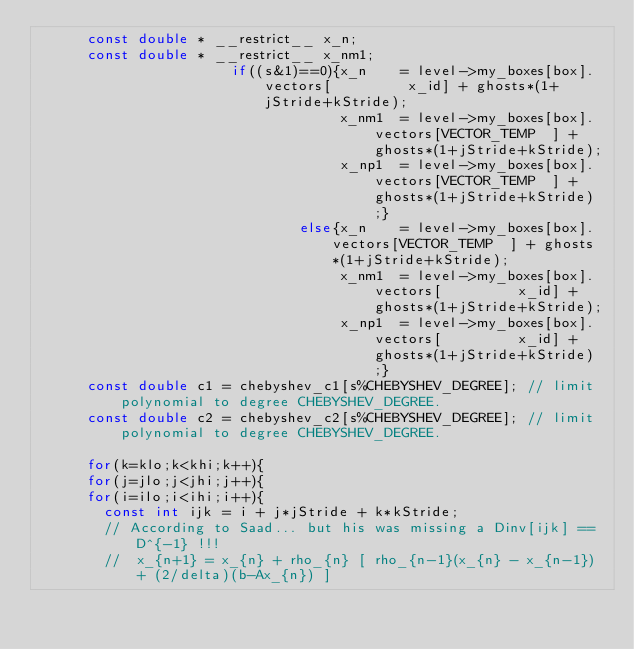Convert code to text. <code><loc_0><loc_0><loc_500><loc_500><_C_>      const double * __restrict__ x_n;
      const double * __restrict__ x_nm1;
                       if((s&1)==0){x_n    = level->my_boxes[box].vectors[         x_id] + ghosts*(1+jStride+kStride);
                                    x_nm1  = level->my_boxes[box].vectors[VECTOR_TEMP  ] + ghosts*(1+jStride+kStride); 
                                    x_np1  = level->my_boxes[box].vectors[VECTOR_TEMP  ] + ghosts*(1+jStride+kStride);}
                               else{x_n    = level->my_boxes[box].vectors[VECTOR_TEMP  ] + ghosts*(1+jStride+kStride);
                                    x_nm1  = level->my_boxes[box].vectors[         x_id] + ghosts*(1+jStride+kStride); 
                                    x_np1  = level->my_boxes[box].vectors[         x_id] + ghosts*(1+jStride+kStride);}
      const double c1 = chebyshev_c1[s%CHEBYSHEV_DEGREE]; // limit polynomial to degree CHEBYSHEV_DEGREE.
      const double c2 = chebyshev_c2[s%CHEBYSHEV_DEGREE]; // limit polynomial to degree CHEBYSHEV_DEGREE.

      for(k=klo;k<khi;k++){
      for(j=jlo;j<jhi;j++){
      for(i=ilo;i<ihi;i++){
        const int ijk = i + j*jStride + k*kStride;
        // According to Saad... but his was missing a Dinv[ijk] == D^{-1} !!!
        //  x_{n+1} = x_{n} + rho_{n} [ rho_{n-1}(x_{n} - x_{n-1}) + (2/delta)(b-Ax_{n}) ]</code> 